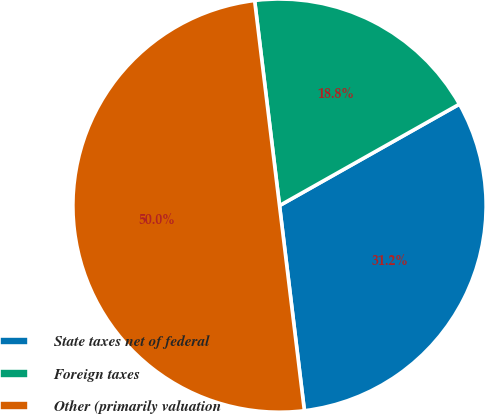<chart> <loc_0><loc_0><loc_500><loc_500><pie_chart><fcel>State taxes net of federal<fcel>Foreign taxes<fcel>Other (primarily valuation<nl><fcel>31.25%<fcel>18.75%<fcel>50.0%<nl></chart> 